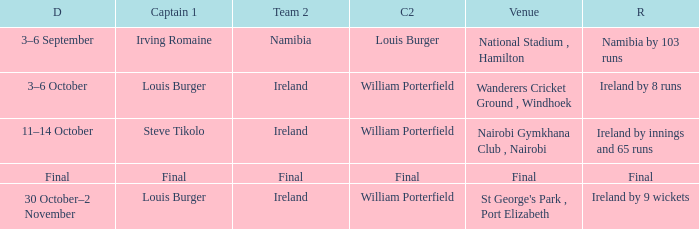Which Captain 2 has a Result of final? Final. 